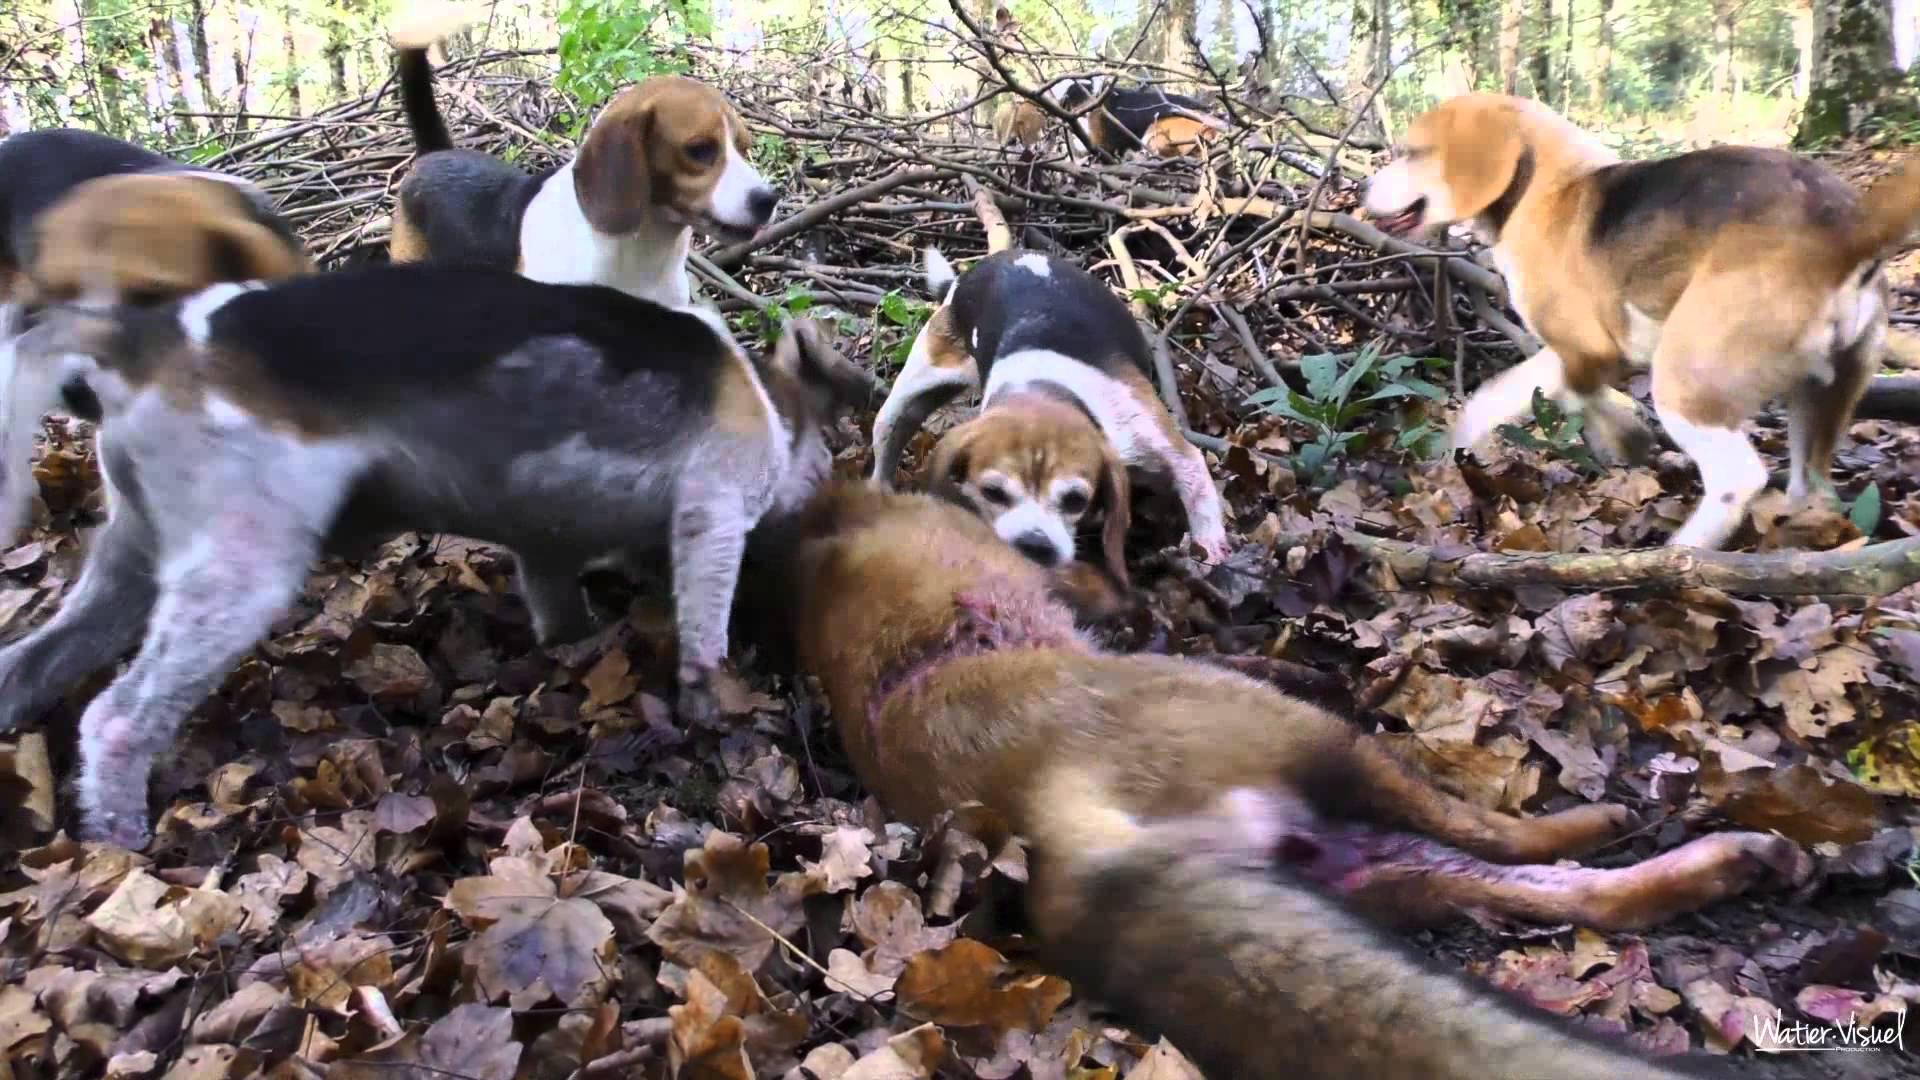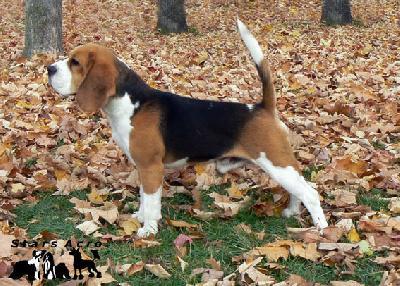The first image is the image on the left, the second image is the image on the right. Assess this claim about the two images: "One dog is standing at attention and facing left.". Correct or not? Answer yes or no. Yes. The first image is the image on the left, the second image is the image on the right. Considering the images on both sides, is "All images include a beagle in an outdoor setting, and at least one image shows multiple beagles behind a prey animal." valid? Answer yes or no. Yes. 